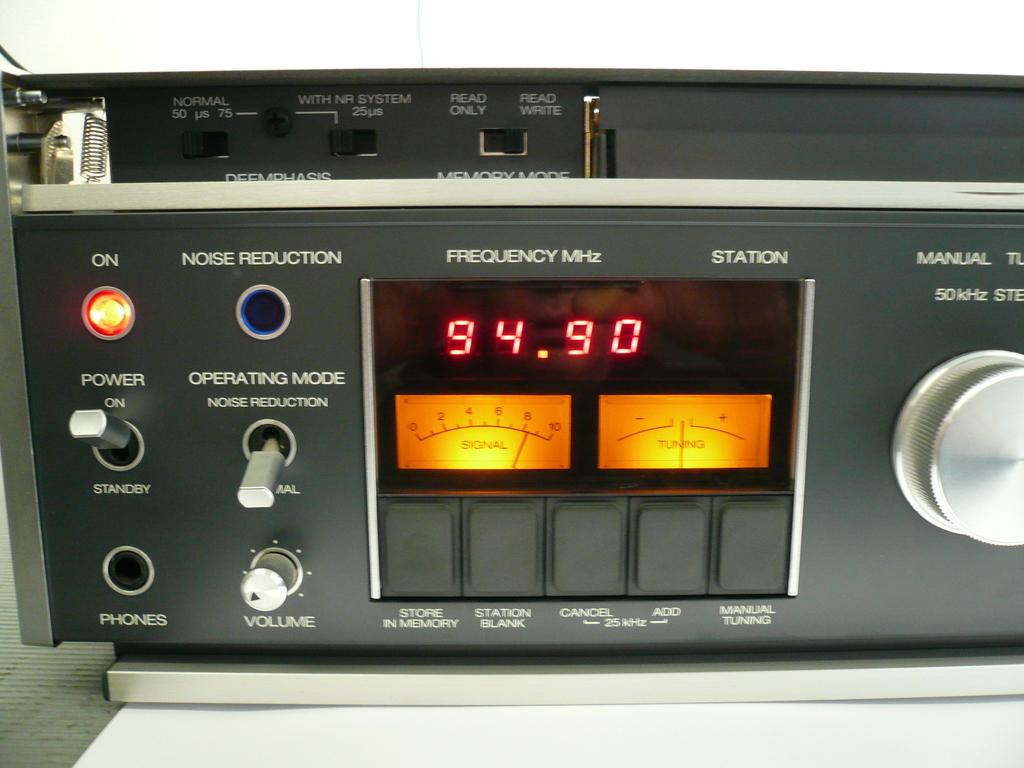Provide a one-sentence caption for the provided image. A piece of electronic equipment that reads a frequency of 94.90 MHz. 